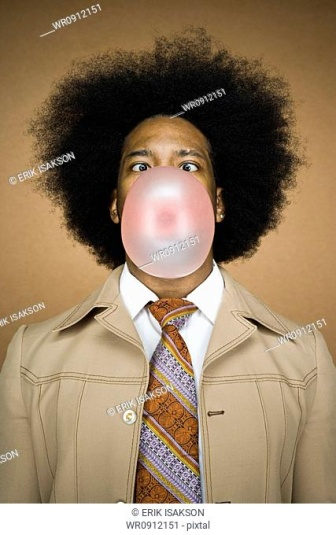Imagine a backstory for the person in the image, explaining why they might be blowing a bubble with gum while dressed formally. Imagine this person, Alex, is a young and quirky marketing professional known for their eccentric style and fun personality. On this particular day, they were attending a brainstorming session for a new bubble gum advertisement campaign at their creative agency. To bring some light-hearted inspiration to the meeting and break the ice, Alex decided to dress in a retro formal outfit, complete with a flashy tie. During a break in the meeting, Alex started blowing a bubble to demonstrate the playful and youthful spirit of the product, resulting in this candid and charming photograph that perfectly captures their vibrant and engaging character. 